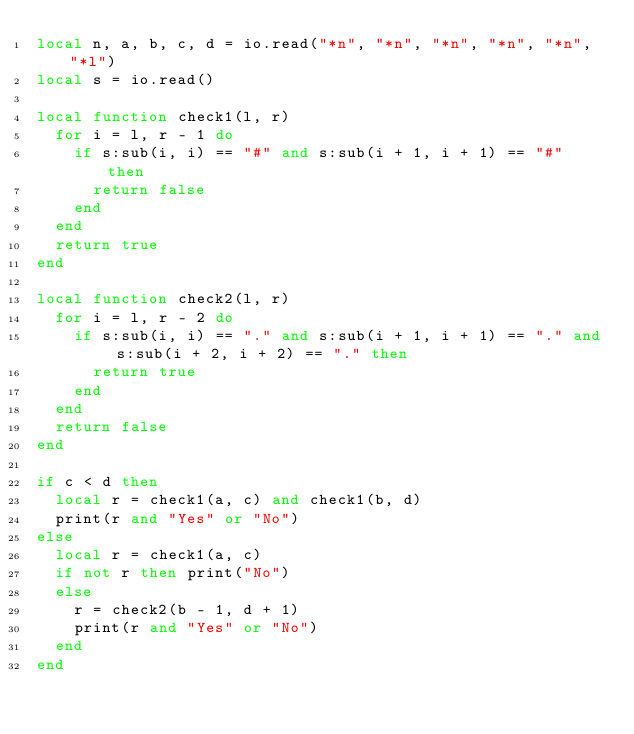<code> <loc_0><loc_0><loc_500><loc_500><_Lua_>local n, a, b, c, d = io.read("*n", "*n", "*n", "*n", "*n", "*l")
local s = io.read()

local function check1(l, r)
  for i = l, r - 1 do
    if s:sub(i, i) == "#" and s:sub(i + 1, i + 1) == "#" then
      return false
    end
  end
  return true
end

local function check2(l, r)
  for i = l, r - 2 do
    if s:sub(i, i) == "." and s:sub(i + 1, i + 1) == "." and s:sub(i + 2, i + 2) == "." then
      return true
    end
  end
  return false
end

if c < d then
  local r = check1(a, c) and check1(b, d)
  print(r and "Yes" or "No")
else
  local r = check1(a, c)
  if not r then print("No")
  else
    r = check2(b - 1, d + 1)
    print(r and "Yes" or "No")
  end
end
</code> 